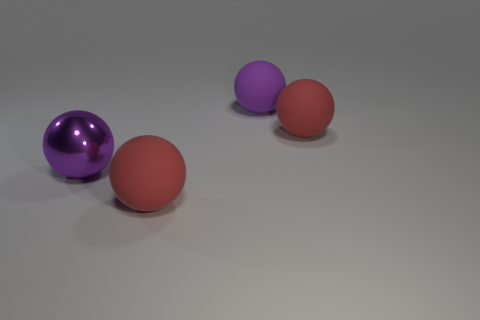Is the number of large spheres right of the big purple shiny thing less than the number of red objects?
Your response must be concise. No. There is a red rubber thing in front of the large purple metal sphere; how many purple shiny spheres are on the right side of it?
Your answer should be very brief. 0. What is the size of the matte object that is both behind the metallic ball and in front of the large purple matte ball?
Your answer should be very brief. Large. Is the number of large metal balls in front of the metal sphere less than the number of large red rubber spheres that are in front of the big purple rubber sphere?
Keep it short and to the point. Yes. What is the large purple object that is right of the large purple metal ball made of?
Offer a very short reply. Rubber. There is a ball that is left of the purple matte object and to the right of the purple metallic thing; what is its color?
Keep it short and to the point. Red. What number of other objects are there of the same color as the shiny object?
Provide a short and direct response. 1. There is a large metallic thing in front of the large purple matte thing; what color is it?
Your answer should be very brief. Purple. Are there any red rubber objects of the same size as the purple rubber ball?
Provide a short and direct response. Yes. There is a purple object that is the same size as the purple matte sphere; what is its material?
Ensure brevity in your answer.  Metal. 